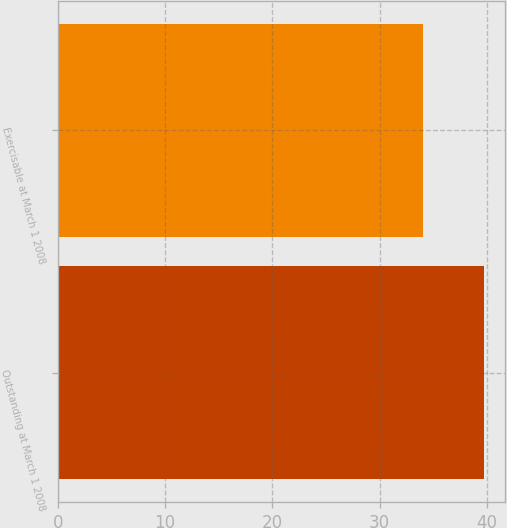Convert chart. <chart><loc_0><loc_0><loc_500><loc_500><bar_chart><fcel>Outstanding at March 1 2008<fcel>Exercisable at March 1 2008<nl><fcel>39.73<fcel>34<nl></chart> 